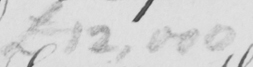Transcribe the text shown in this historical manuscript line. £12,000 